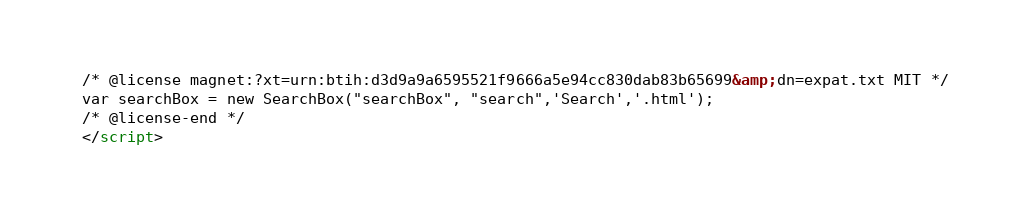Convert code to text. <code><loc_0><loc_0><loc_500><loc_500><_HTML_>/* @license magnet:?xt=urn:btih:d3d9a9a6595521f9666a5e94cc830dab83b65699&amp;dn=expat.txt MIT */
var searchBox = new SearchBox("searchBox", "search",'Search','.html');
/* @license-end */
</script></code> 